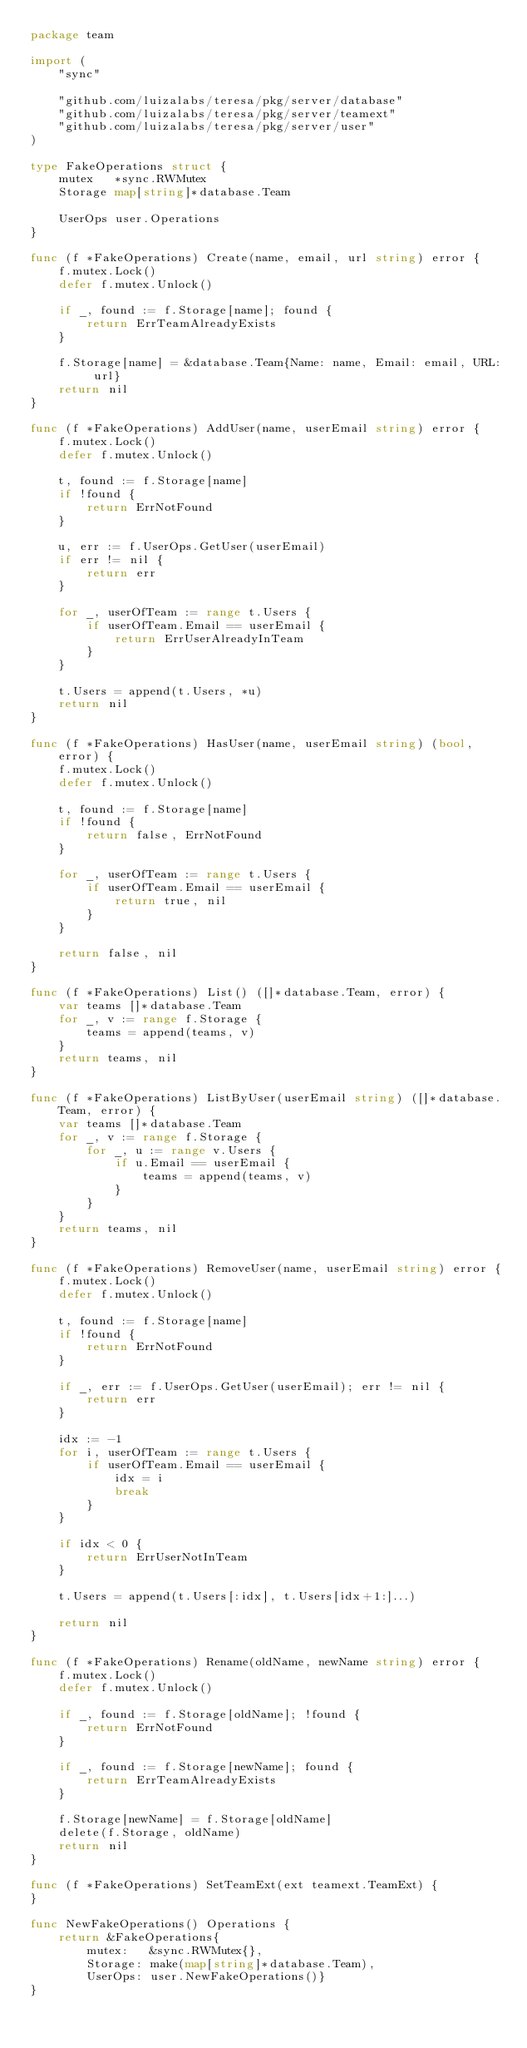Convert code to text. <code><loc_0><loc_0><loc_500><loc_500><_Go_>package team

import (
	"sync"

	"github.com/luizalabs/teresa/pkg/server/database"
	"github.com/luizalabs/teresa/pkg/server/teamext"
	"github.com/luizalabs/teresa/pkg/server/user"
)

type FakeOperations struct {
	mutex   *sync.RWMutex
	Storage map[string]*database.Team

	UserOps user.Operations
}

func (f *FakeOperations) Create(name, email, url string) error {
	f.mutex.Lock()
	defer f.mutex.Unlock()

	if _, found := f.Storage[name]; found {
		return ErrTeamAlreadyExists
	}

	f.Storage[name] = &database.Team{Name: name, Email: email, URL: url}
	return nil
}

func (f *FakeOperations) AddUser(name, userEmail string) error {
	f.mutex.Lock()
	defer f.mutex.Unlock()

	t, found := f.Storage[name]
	if !found {
		return ErrNotFound
	}

	u, err := f.UserOps.GetUser(userEmail)
	if err != nil {
		return err
	}

	for _, userOfTeam := range t.Users {
		if userOfTeam.Email == userEmail {
			return ErrUserAlreadyInTeam
		}
	}

	t.Users = append(t.Users, *u)
	return nil
}

func (f *FakeOperations) HasUser(name, userEmail string) (bool, error) {
	f.mutex.Lock()
	defer f.mutex.Unlock()

	t, found := f.Storage[name]
	if !found {
		return false, ErrNotFound
	}

	for _, userOfTeam := range t.Users {
		if userOfTeam.Email == userEmail {
			return true, nil
		}
	}

	return false, nil
}

func (f *FakeOperations) List() ([]*database.Team, error) {
	var teams []*database.Team
	for _, v := range f.Storage {
		teams = append(teams, v)
	}
	return teams, nil
}

func (f *FakeOperations) ListByUser(userEmail string) ([]*database.Team, error) {
	var teams []*database.Team
	for _, v := range f.Storage {
		for _, u := range v.Users {
			if u.Email == userEmail {
				teams = append(teams, v)
			}
		}
	}
	return teams, nil
}

func (f *FakeOperations) RemoveUser(name, userEmail string) error {
	f.mutex.Lock()
	defer f.mutex.Unlock()

	t, found := f.Storage[name]
	if !found {
		return ErrNotFound
	}

	if _, err := f.UserOps.GetUser(userEmail); err != nil {
		return err
	}

	idx := -1
	for i, userOfTeam := range t.Users {
		if userOfTeam.Email == userEmail {
			idx = i
			break
		}
	}

	if idx < 0 {
		return ErrUserNotInTeam
	}

	t.Users = append(t.Users[:idx], t.Users[idx+1:]...)

	return nil
}

func (f *FakeOperations) Rename(oldName, newName string) error {
	f.mutex.Lock()
	defer f.mutex.Unlock()

	if _, found := f.Storage[oldName]; !found {
		return ErrNotFound
	}

	if _, found := f.Storage[newName]; found {
		return ErrTeamAlreadyExists
	}

	f.Storage[newName] = f.Storage[oldName]
	delete(f.Storage, oldName)
	return nil
}

func (f *FakeOperations) SetTeamExt(ext teamext.TeamExt) {
}

func NewFakeOperations() Operations {
	return &FakeOperations{
		mutex:   &sync.RWMutex{},
		Storage: make(map[string]*database.Team),
		UserOps: user.NewFakeOperations()}
}
</code> 